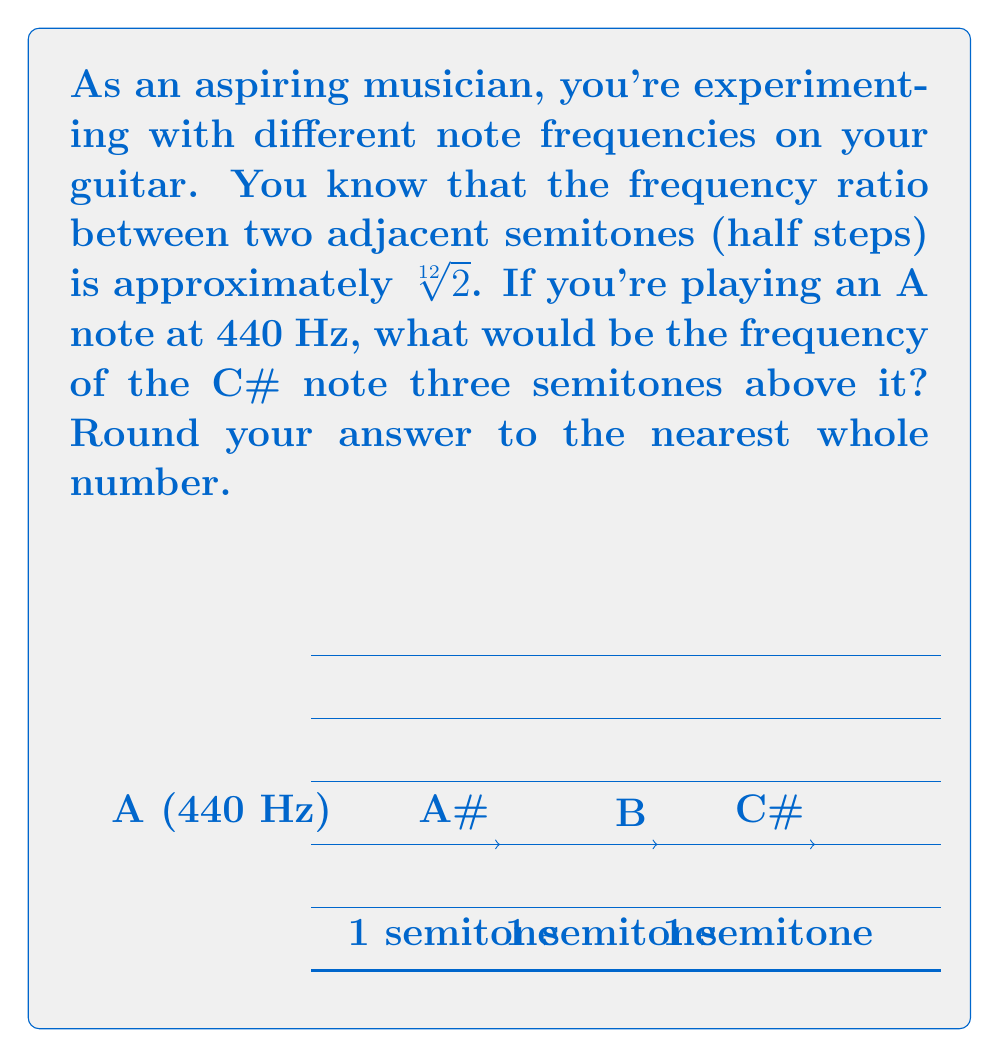Give your solution to this math problem. Let's approach this step-by-step:

1) We know that the frequency ratio between two adjacent semitones is $\sqrt[12]{2}$.

2) We need to go up three semitones from A to C#. This means we need to multiply the frequency by $(\sqrt[12]{2})^3$.

3) Let's calculate this:
   
   $$f_{C\#} = 440 \cdot (\sqrt[12]{2})^3$$

4) We can simplify this:
   
   $$f_{C\#} = 440 \cdot \sqrt[4]{2}$$

5) Now, let's calculate this:
   
   $$f_{C\#} = 440 \cdot 1.189207115$$
   
   $$f_{C\#} = 523.2511306$$

6) Rounding to the nearest whole number:
   
   $$f_{C\#} \approx 523 \text{ Hz}$$

Thus, the C# note three semitones above A (440 Hz) has a frequency of approximately 523 Hz.
Answer: 523 Hz 